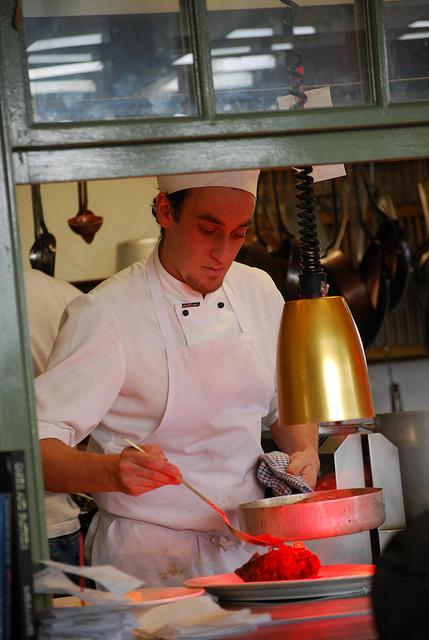What is the man doing?
Be succinct. Cooking. Does the man have a spoon?
Be succinct. Yes. Is it likely that he has a food handler's permit?
Short answer required. Yes. What is this person's job?
Keep it brief. Chef. 